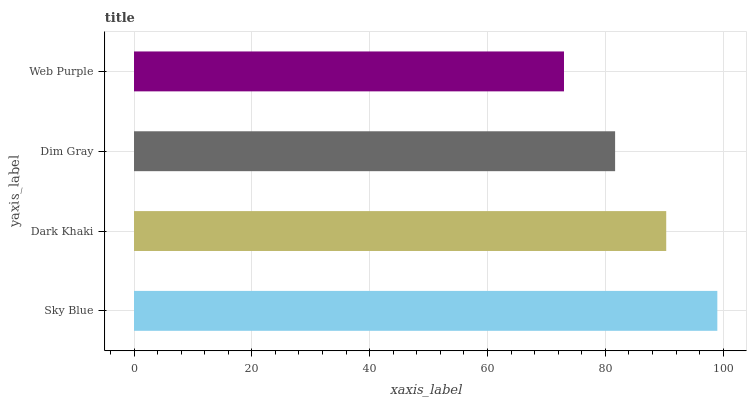Is Web Purple the minimum?
Answer yes or no. Yes. Is Sky Blue the maximum?
Answer yes or no. Yes. Is Dark Khaki the minimum?
Answer yes or no. No. Is Dark Khaki the maximum?
Answer yes or no. No. Is Sky Blue greater than Dark Khaki?
Answer yes or no. Yes. Is Dark Khaki less than Sky Blue?
Answer yes or no. Yes. Is Dark Khaki greater than Sky Blue?
Answer yes or no. No. Is Sky Blue less than Dark Khaki?
Answer yes or no. No. Is Dark Khaki the high median?
Answer yes or no. Yes. Is Dim Gray the low median?
Answer yes or no. Yes. Is Sky Blue the high median?
Answer yes or no. No. Is Dark Khaki the low median?
Answer yes or no. No. 